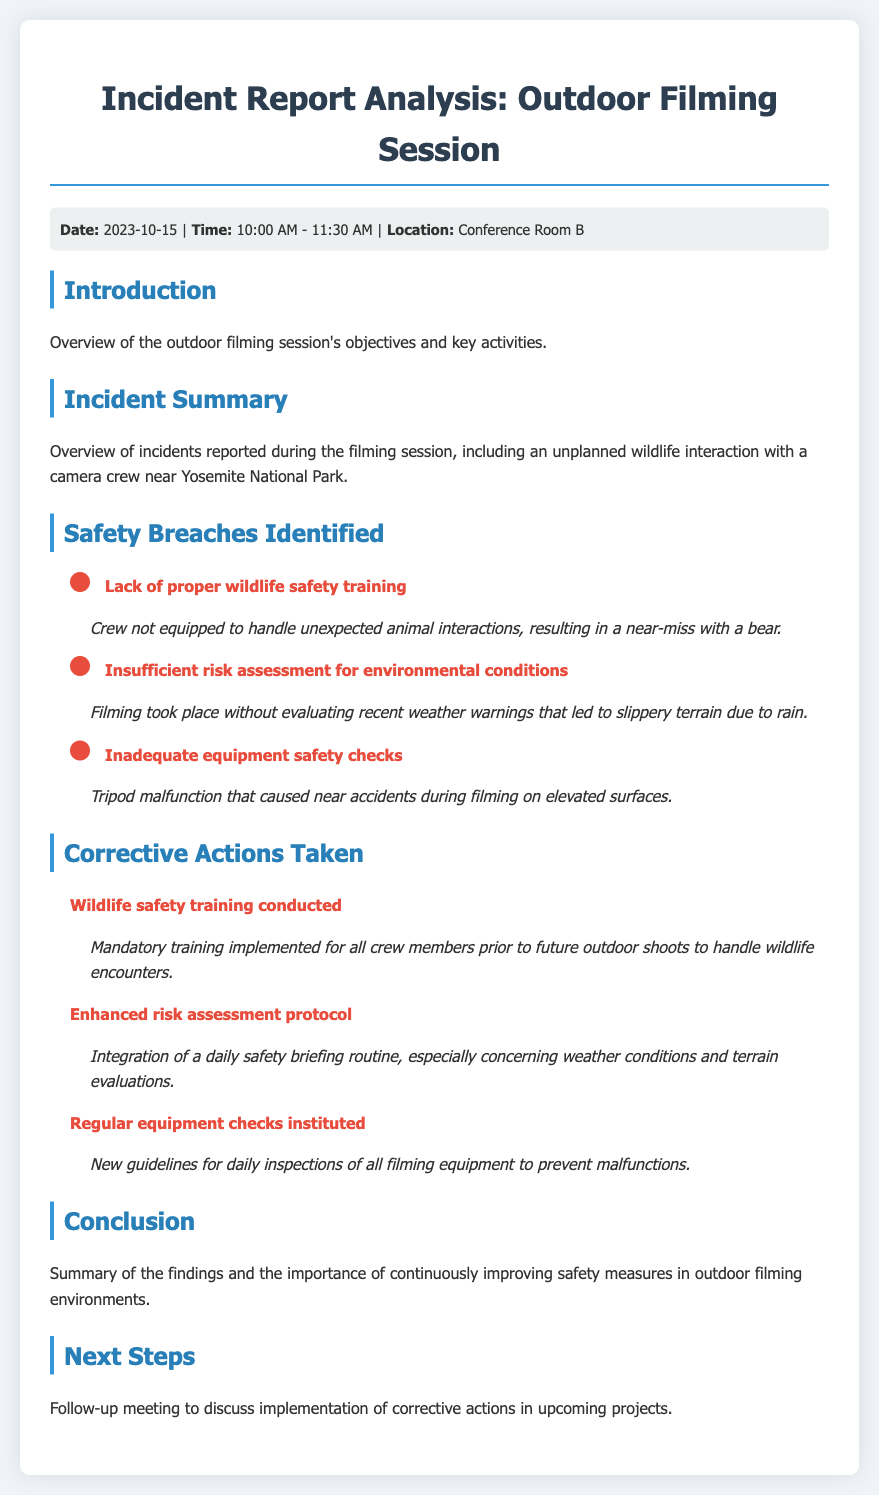what was the date of the filming session? The date of the outdoor filming session is mentioned in the meta-info section of the document.
Answer: 2023-10-15 what were the filming hours? The document specifies the time of the filming session in the meta-info section.
Answer: 10:00 AM - 11:30 AM what is one identified safety breach? The section on safety breaches lists instances of safety issues, and one specific breach is mentioned.
Answer: Lack of proper wildlife safety training what corrective action involved wildlife safety? The corrective actions taken after the incident report include specific steps implemented for wildlife encounters.
Answer: Wildlife safety training conducted how many safety breaches were identified? The document includes a list of safety breaches, and the number can be counted.
Answer: Three what is one component of the enhanced risk assessment? The section outlines the elements of the new risk assessment protocols implemented after the report.
Answer: Daily safety briefing routine who conducted the wildlife safety training? The document does not specify a name but indicates that training was implemented for all crew members.
Answer: Crew members why is it important to continuously improve safety measures? The conclusion section addresses the significance of ongoing enhancements in safety protocols.
Answer: To improve safety measures when is the follow-up meeting planned? The next steps section mentions the discussion point for an upcoming meeting related to corrective actions.
Answer: Upcoming projects 